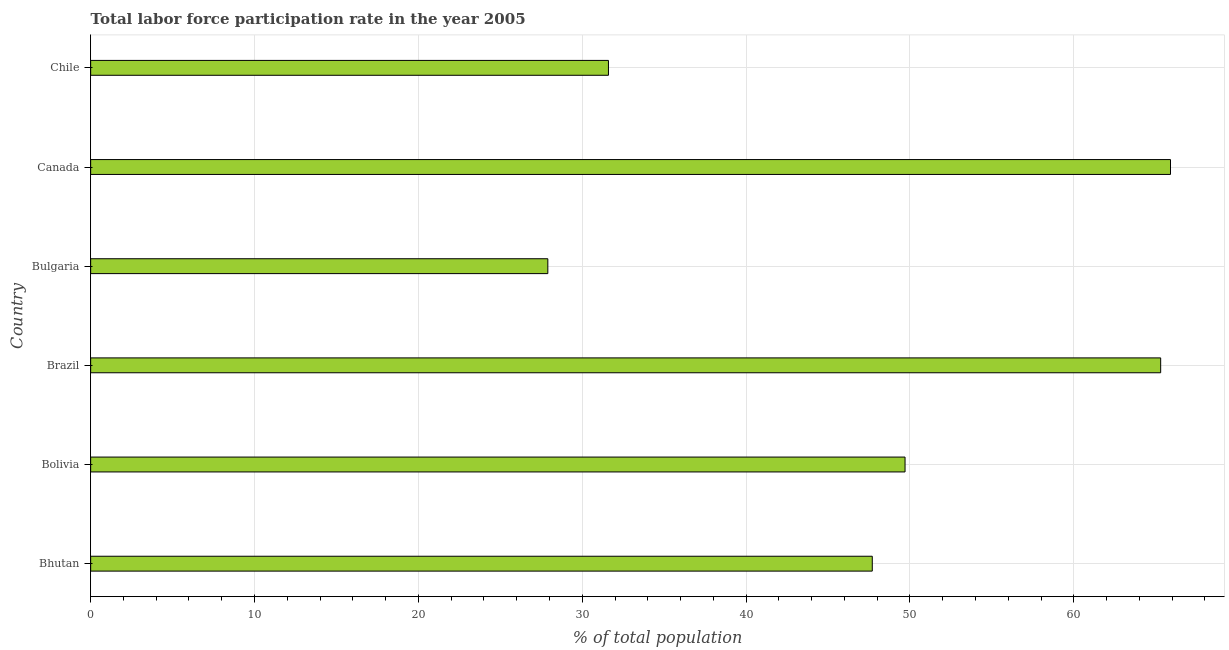Does the graph contain any zero values?
Your response must be concise. No. Does the graph contain grids?
Your answer should be compact. Yes. What is the title of the graph?
Your answer should be compact. Total labor force participation rate in the year 2005. What is the label or title of the X-axis?
Provide a succinct answer. % of total population. What is the label or title of the Y-axis?
Offer a very short reply. Country. What is the total labor force participation rate in Canada?
Provide a short and direct response. 65.9. Across all countries, what is the maximum total labor force participation rate?
Your answer should be very brief. 65.9. Across all countries, what is the minimum total labor force participation rate?
Your answer should be very brief. 27.9. In which country was the total labor force participation rate maximum?
Provide a succinct answer. Canada. What is the sum of the total labor force participation rate?
Provide a succinct answer. 288.1. What is the difference between the total labor force participation rate in Bulgaria and Canada?
Ensure brevity in your answer.  -38. What is the average total labor force participation rate per country?
Make the answer very short. 48.02. What is the median total labor force participation rate?
Offer a terse response. 48.7. In how many countries, is the total labor force participation rate greater than 38 %?
Your answer should be very brief. 4. What is the ratio of the total labor force participation rate in Bhutan to that in Canada?
Provide a succinct answer. 0.72. What is the difference between the highest and the second highest total labor force participation rate?
Your response must be concise. 0.6. What is the difference between the highest and the lowest total labor force participation rate?
Your answer should be very brief. 38. In how many countries, is the total labor force participation rate greater than the average total labor force participation rate taken over all countries?
Provide a short and direct response. 3. Are all the bars in the graph horizontal?
Your response must be concise. Yes. How many countries are there in the graph?
Your answer should be very brief. 6. What is the % of total population of Bhutan?
Ensure brevity in your answer.  47.7. What is the % of total population in Bolivia?
Keep it short and to the point. 49.7. What is the % of total population in Brazil?
Provide a short and direct response. 65.3. What is the % of total population of Bulgaria?
Offer a terse response. 27.9. What is the % of total population of Canada?
Make the answer very short. 65.9. What is the % of total population of Chile?
Offer a very short reply. 31.6. What is the difference between the % of total population in Bhutan and Brazil?
Make the answer very short. -17.6. What is the difference between the % of total population in Bhutan and Bulgaria?
Your answer should be very brief. 19.8. What is the difference between the % of total population in Bhutan and Canada?
Keep it short and to the point. -18.2. What is the difference between the % of total population in Bolivia and Brazil?
Make the answer very short. -15.6. What is the difference between the % of total population in Bolivia and Bulgaria?
Your response must be concise. 21.8. What is the difference between the % of total population in Bolivia and Canada?
Give a very brief answer. -16.2. What is the difference between the % of total population in Brazil and Bulgaria?
Ensure brevity in your answer.  37.4. What is the difference between the % of total population in Brazil and Chile?
Provide a succinct answer. 33.7. What is the difference between the % of total population in Bulgaria and Canada?
Your answer should be compact. -38. What is the difference between the % of total population in Canada and Chile?
Offer a terse response. 34.3. What is the ratio of the % of total population in Bhutan to that in Bolivia?
Your answer should be compact. 0.96. What is the ratio of the % of total population in Bhutan to that in Brazil?
Offer a terse response. 0.73. What is the ratio of the % of total population in Bhutan to that in Bulgaria?
Keep it short and to the point. 1.71. What is the ratio of the % of total population in Bhutan to that in Canada?
Your response must be concise. 0.72. What is the ratio of the % of total population in Bhutan to that in Chile?
Your answer should be very brief. 1.51. What is the ratio of the % of total population in Bolivia to that in Brazil?
Keep it short and to the point. 0.76. What is the ratio of the % of total population in Bolivia to that in Bulgaria?
Give a very brief answer. 1.78. What is the ratio of the % of total population in Bolivia to that in Canada?
Keep it short and to the point. 0.75. What is the ratio of the % of total population in Bolivia to that in Chile?
Offer a very short reply. 1.57. What is the ratio of the % of total population in Brazil to that in Bulgaria?
Ensure brevity in your answer.  2.34. What is the ratio of the % of total population in Brazil to that in Canada?
Ensure brevity in your answer.  0.99. What is the ratio of the % of total population in Brazil to that in Chile?
Offer a terse response. 2.07. What is the ratio of the % of total population in Bulgaria to that in Canada?
Offer a terse response. 0.42. What is the ratio of the % of total population in Bulgaria to that in Chile?
Offer a very short reply. 0.88. What is the ratio of the % of total population in Canada to that in Chile?
Provide a succinct answer. 2.08. 